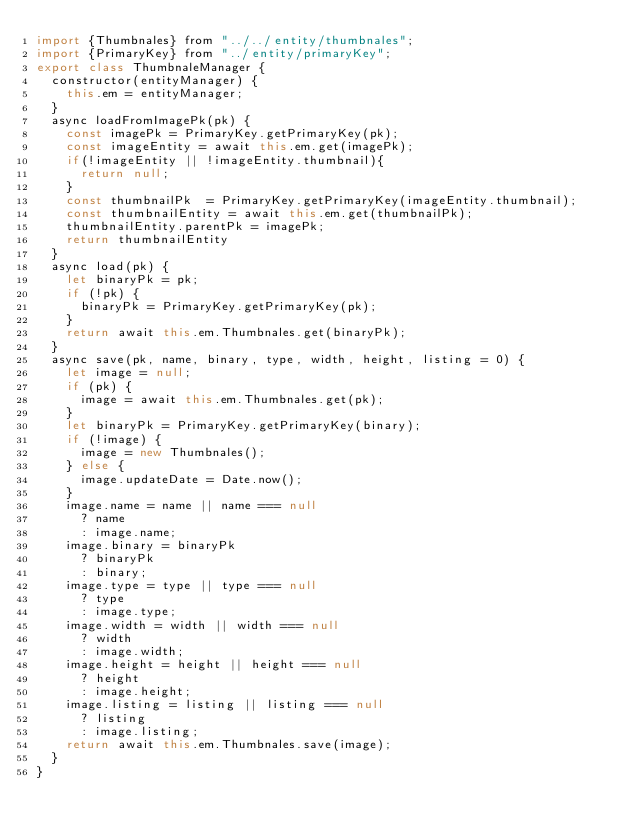Convert code to text. <code><loc_0><loc_0><loc_500><loc_500><_JavaScript_>import {Thumbnales} from "../../entity/thumbnales";
import {PrimaryKey} from "../entity/primaryKey";
export class ThumbnaleManager {
  constructor(entityManager) {
    this.em = entityManager;
  }
  async loadFromImagePk(pk) {
    const imagePk = PrimaryKey.getPrimaryKey(pk);
    const imageEntity = await this.em.get(imagePk);
    if(!imageEntity || !imageEntity.thumbnail){
      return null;
    }
    const thumbnailPk  = PrimaryKey.getPrimaryKey(imageEntity.thumbnail);
    const thumbnailEntity = await this.em.get(thumbnailPk);
    thumbnailEntity.parentPk = imagePk;
    return thumbnailEntity
  }
  async load(pk) {
    let binaryPk = pk;
    if (!pk) {
      binaryPk = PrimaryKey.getPrimaryKey(pk);
    }
    return await this.em.Thumbnales.get(binaryPk);
  }
  async save(pk, name, binary, type, width, height, listing = 0) {
    let image = null;
    if (pk) {
      image = await this.em.Thumbnales.get(pk);
    }
    let binaryPk = PrimaryKey.getPrimaryKey(binary);
    if (!image) {
      image = new Thumbnales();
    } else {
      image.updateDate = Date.now();
    }
    image.name = name || name === null
      ? name
      : image.name;
    image.binary = binaryPk
      ? binaryPk
      : binary;
    image.type = type || type === null
      ? type
      : image.type;
    image.width = width || width === null
      ? width
      : image.width;
    image.height = height || height === null
      ? height
      : image.height;
    image.listing = listing || listing === null
      ? listing
      : image.listing;
    return await this.em.Thumbnales.save(image);
  }
}
</code> 